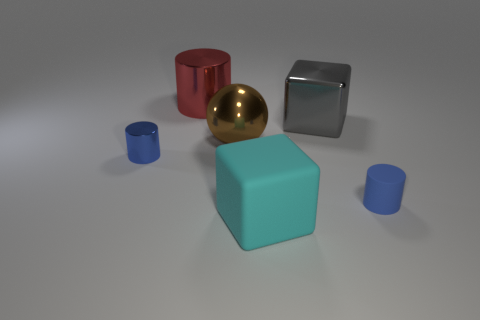Add 3 yellow shiny cylinders. How many objects exist? 9 Subtract all spheres. How many objects are left? 5 Add 4 big metallic things. How many big metallic things exist? 7 Subtract 0 purple balls. How many objects are left? 6 Subtract all shiny things. Subtract all small blue objects. How many objects are left? 0 Add 1 blue rubber things. How many blue rubber things are left? 2 